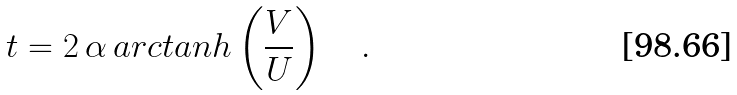Convert formula to latex. <formula><loc_0><loc_0><loc_500><loc_500>t = 2 \, \alpha \, a r c t a n h \left ( \frac { V } { U } \right ) \quad .</formula> 